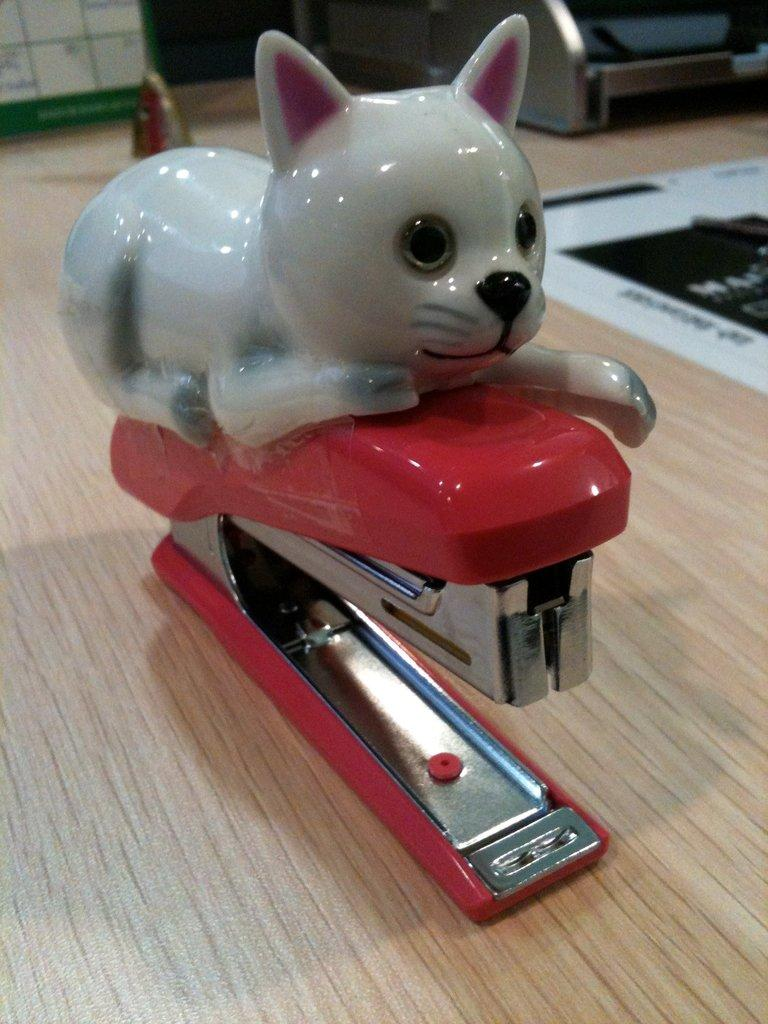What object is the main focus of the image? There is a red stapler in the image. What is placed on top of the stapler? There is a small cat toy on top of the stapler. On what surface are the stapler and cat toy placed? The stapler and cat toy are placed on a wooden table. What type of horn can be seen erupting from the volcano in the image? There is no volcano or horn present in the image; it features a red stapler with a small cat toy on top, placed on a wooden table. 